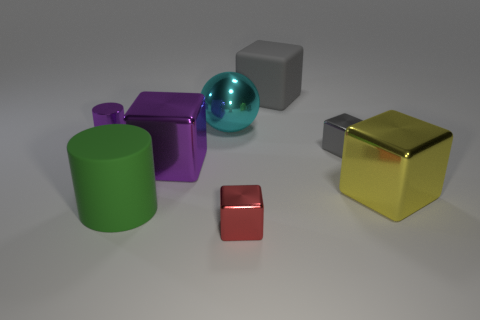Are there any patterns or textures on the objects? No patterns are visible, but there are distinct textures. The green cylinder and purple cube are smooth with a matte finish. The golden cube has a slightly textured surface that catches light differently, creating a sense of depth. The red box has a subtle gradient effect, while the turquoise sphere is highly reflective, resulting in a smooth and glossy texture that mirrors the surroundings. 